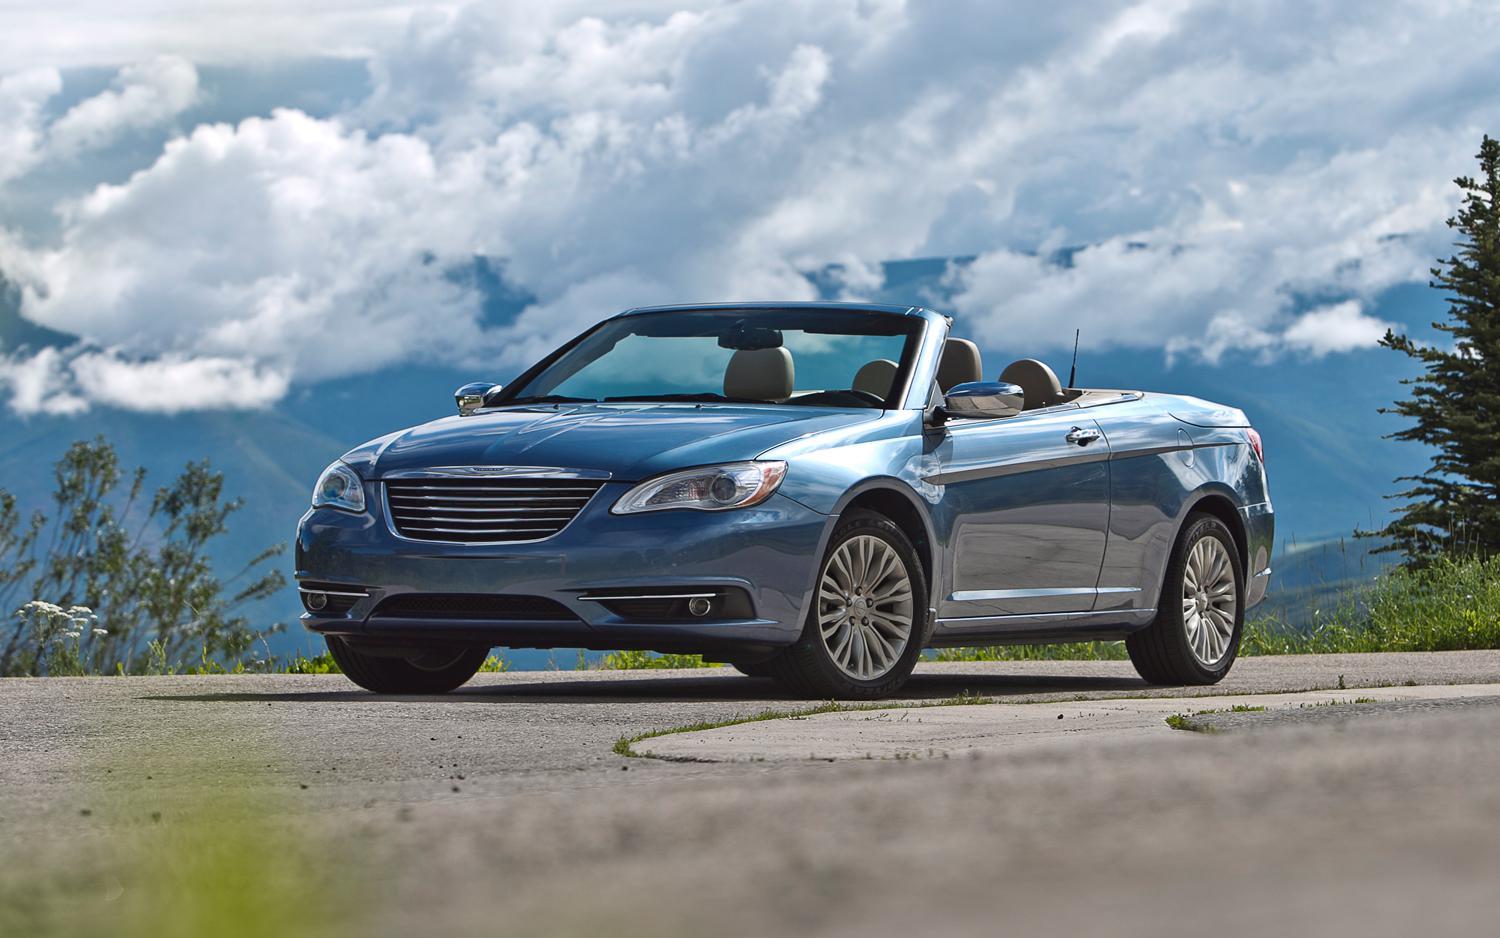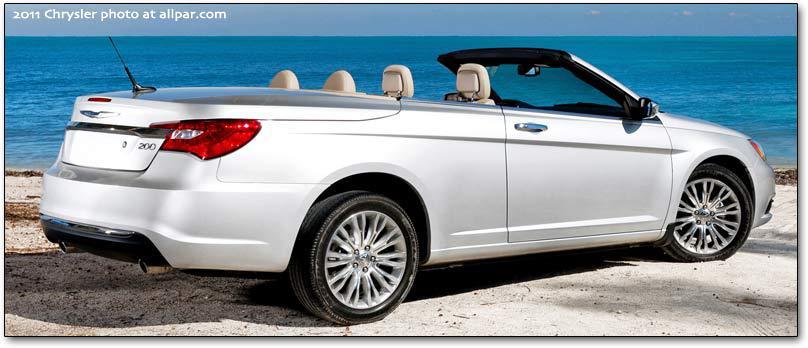The first image is the image on the left, the second image is the image on the right. For the images shown, is this caption "In the left image, there is a single blue convertible with its top down" true? Answer yes or no. Yes. The first image is the image on the left, the second image is the image on the right. For the images shown, is this caption "The left image contains only one car and it is blue." true? Answer yes or no. Yes. 